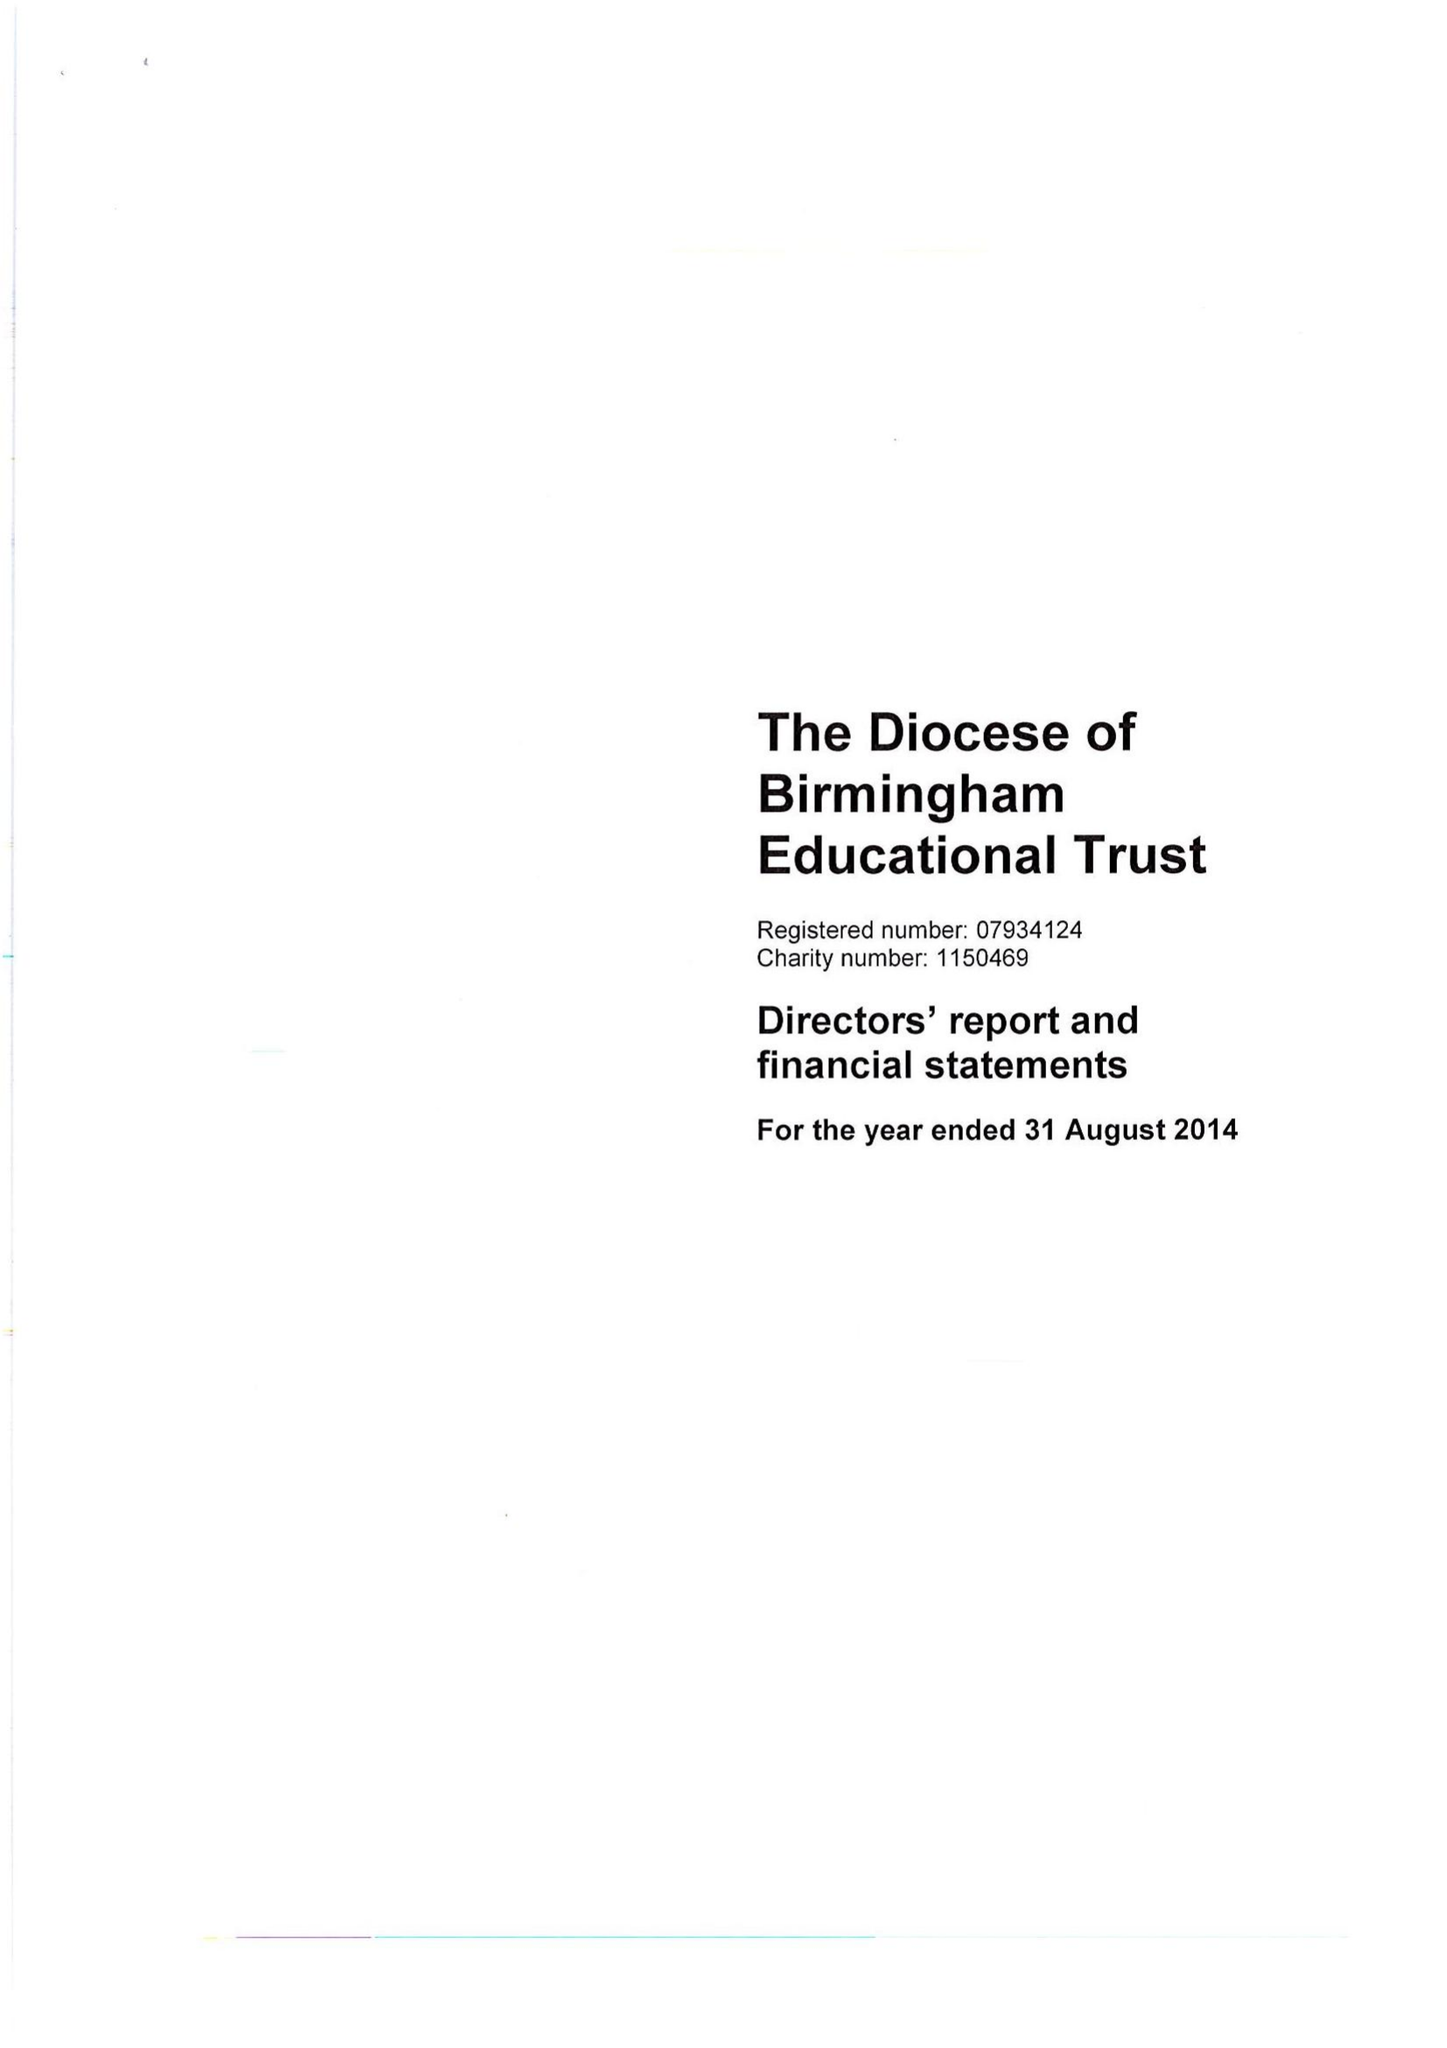What is the value for the report_date?
Answer the question using a single word or phrase. 2014-08-31 